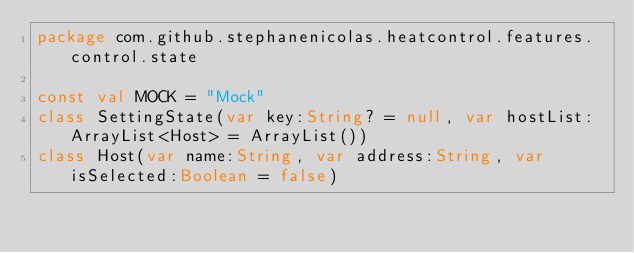Convert code to text. <code><loc_0><loc_0><loc_500><loc_500><_Kotlin_>package com.github.stephanenicolas.heatcontrol.features.control.state

const val MOCK = "Mock"
class SettingState(var key:String? = null, var hostList:ArrayList<Host> = ArrayList())
class Host(var name:String, var address:String, var isSelected:Boolean = false)
</code> 